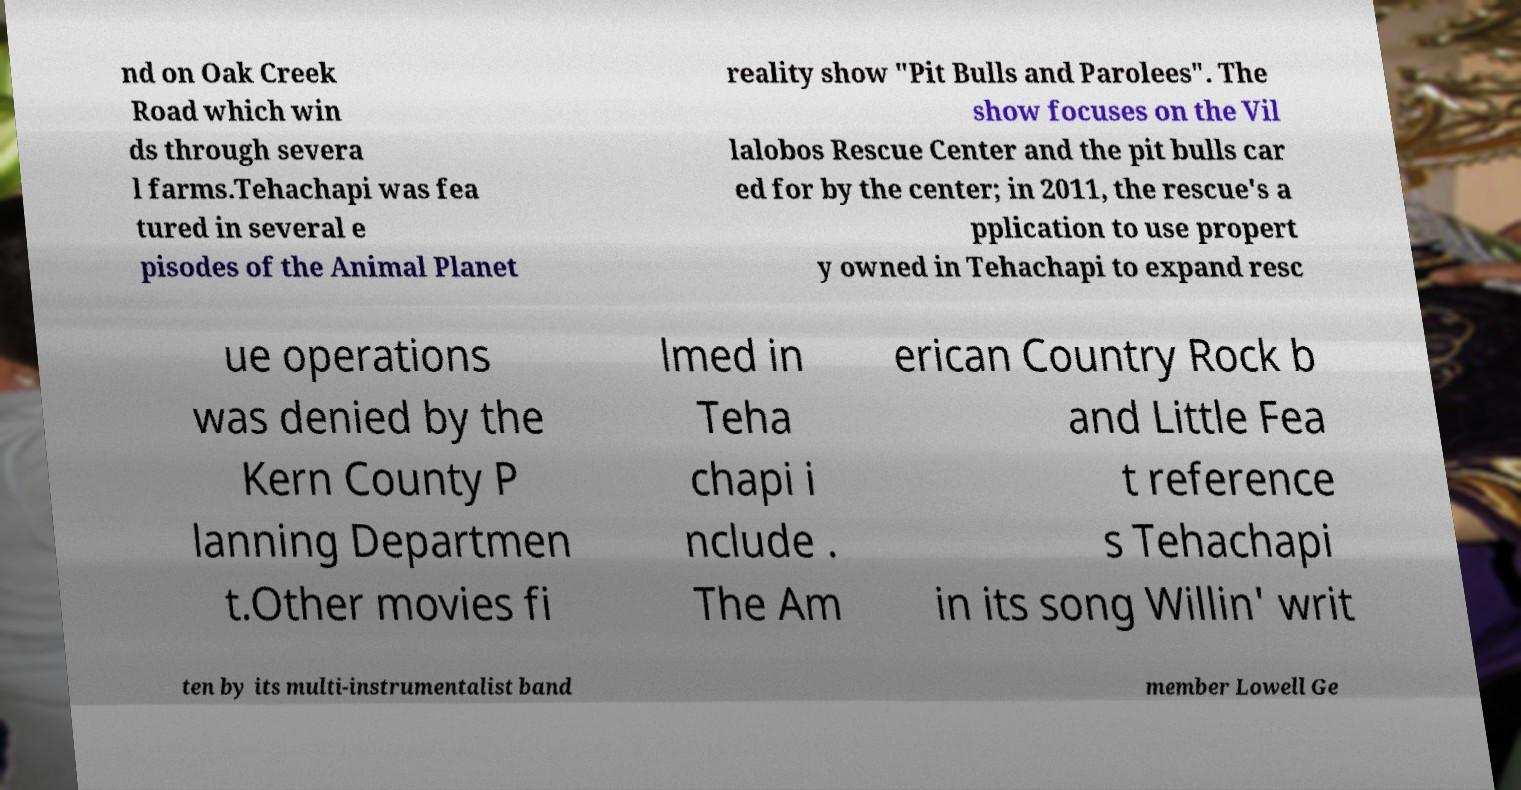Could you extract and type out the text from this image? nd on Oak Creek Road which win ds through severa l farms.Tehachapi was fea tured in several e pisodes of the Animal Planet reality show "Pit Bulls and Parolees". The show focuses on the Vil lalobos Rescue Center and the pit bulls car ed for by the center; in 2011, the rescue's a pplication to use propert y owned in Tehachapi to expand resc ue operations was denied by the Kern County P lanning Departmen t.Other movies fi lmed in Teha chapi i nclude . The Am erican Country Rock b and Little Fea t reference s Tehachapi in its song Willin' writ ten by its multi-instrumentalist band member Lowell Ge 